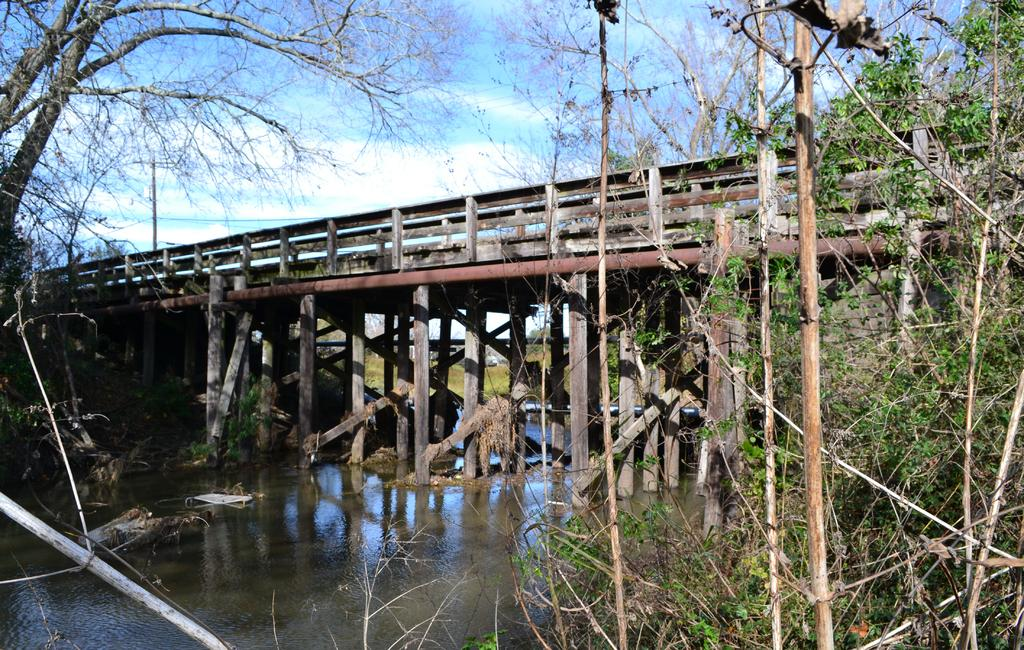What structure can be seen in the image? There is a bridge in the image. Where is the bridge situated? The bridge is located above water. What type of vegetation is visible in the image? There are trees visible in the image. What type of drink is being served on the bridge in the image? There is no drink or service present on the bridge in the image. 